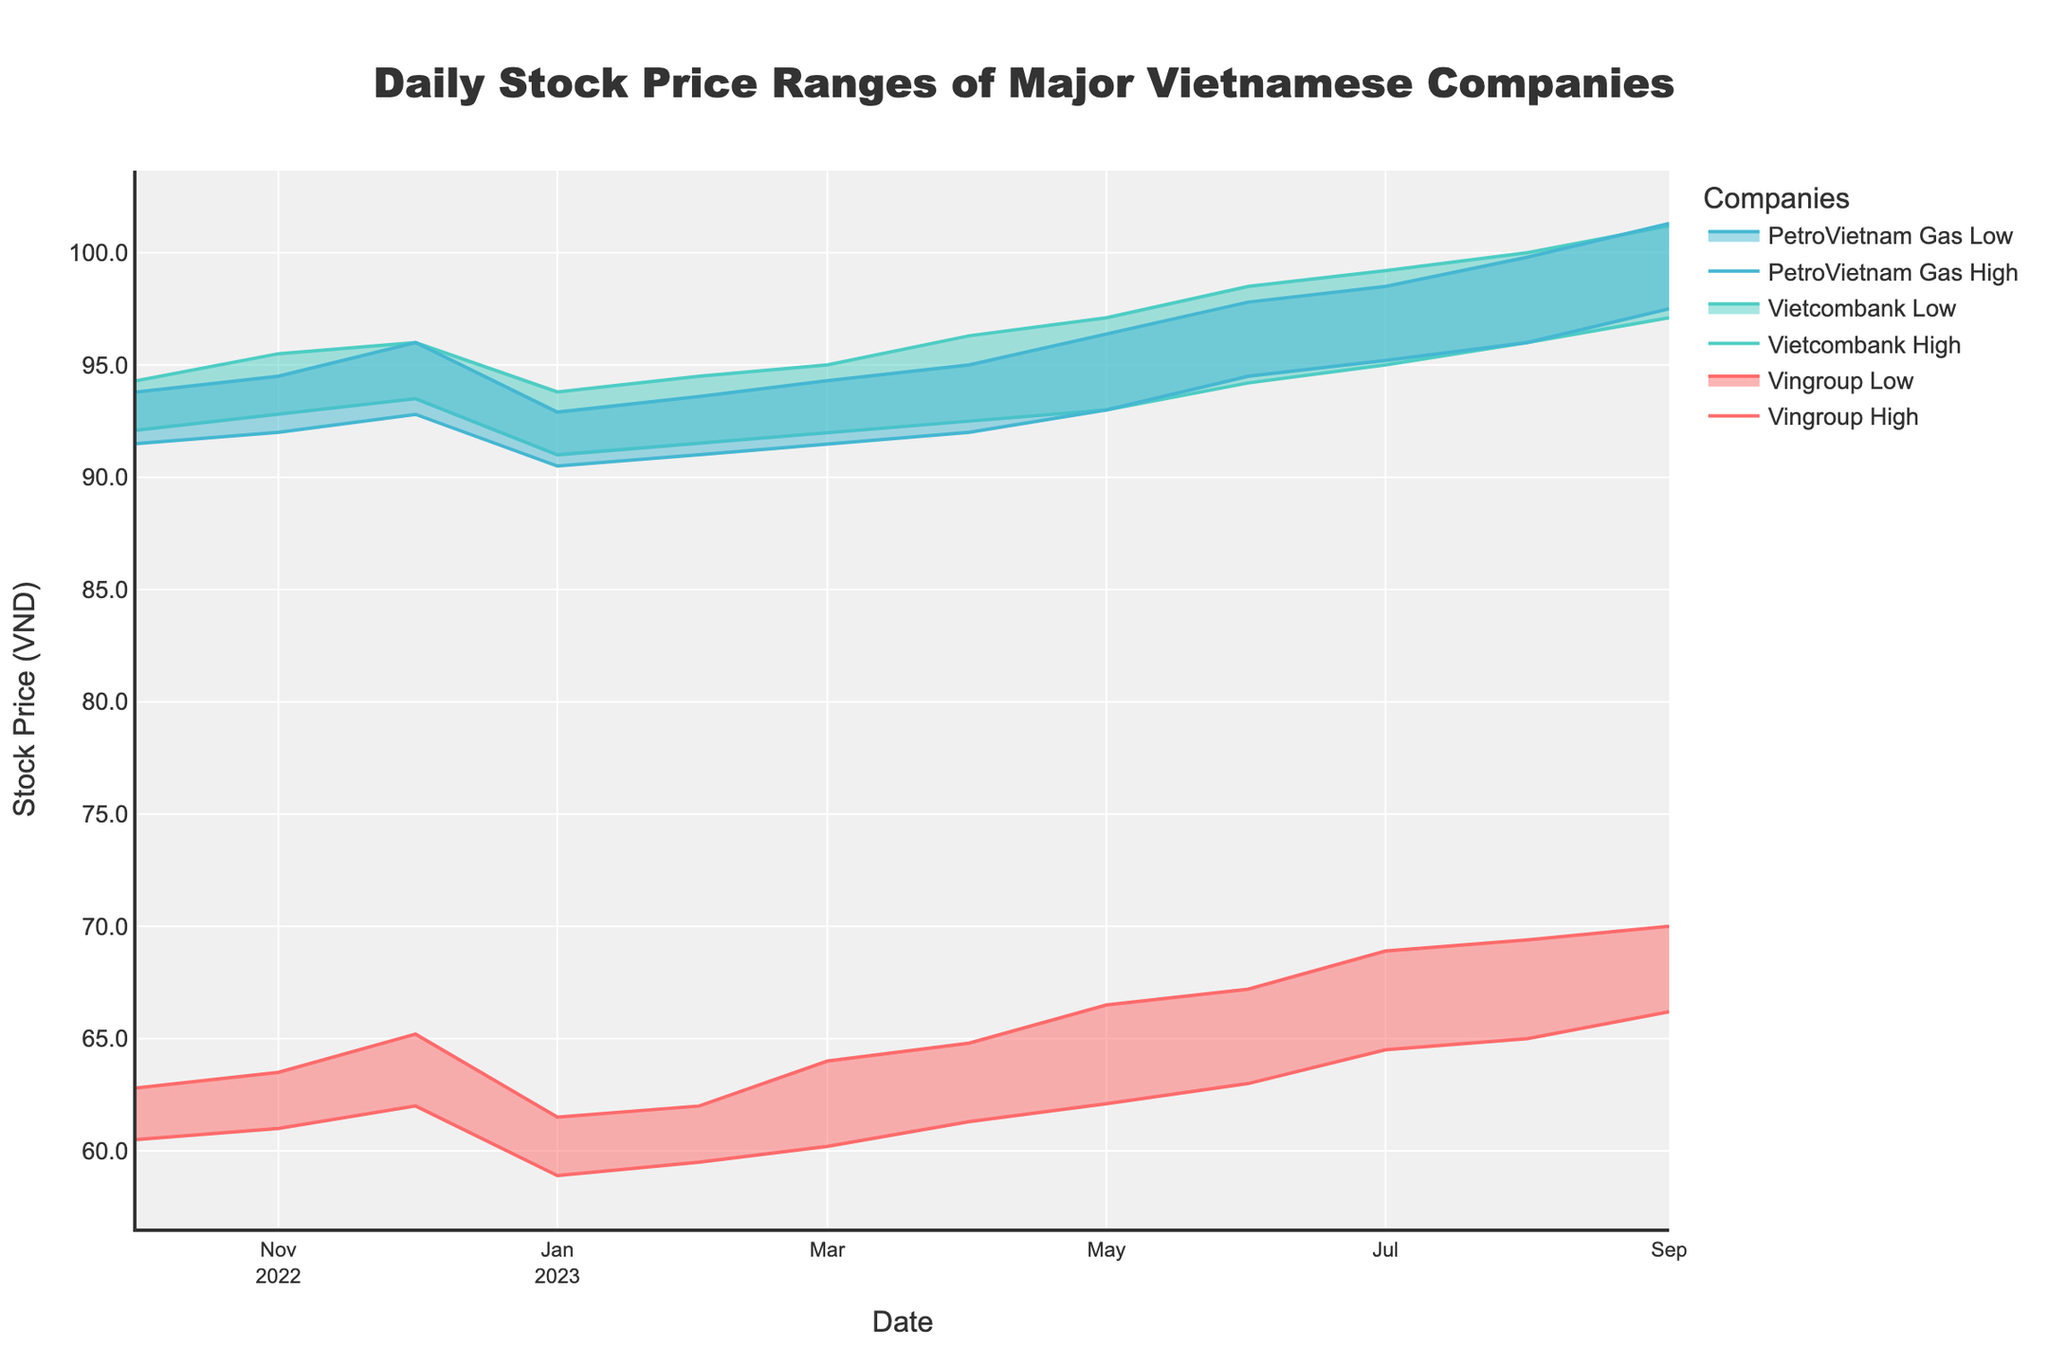what is the color used for Vingroup stock prices? The color assigned to Vingroup stock prices is evident from the lines representing Vingroup in the chart.
Answer: Red In April 2023, what was the difference between the high and low prices of Vingroup’s stock? In the chart, find the high and low prices of Vingroup in April 2023. The high price is 64.8 and the low price is 61.3. The difference is 64.8 - 61.3 = 3.5.
Answer: 3.5 How did the stock range for Vietcombank change from October 2022 to September 2023? To understand the change, observe Vietcombank's high and low prices in October 2022 (94.3 and 92.1 respectively) and September 2023 (101.2 and 97.1 respectively). The range increased from 2.2 in October 2022 to 4.1 in September 2023.
Answer: It increased Comparing Vingroup and Vietcombank, which company had the higher peak stock price over the past year? Identify the highest peak prices for both companies. Vingroup's peak is 70.0 in September 2023, while Vietcombank's peak is 101.2 in September 2023.
Answer: Vietcombank What month did PetroVietnam Gas first exceed a high stock price of 97? Look for the first month where PetroVietnam Gas's high stock price exceeds 97. This occurred in June 2023.
Answer: June 2023 Which company had the smallest increase in low stock price from October 2022 to September 2023? Calculate the increase in low stock prices for each company. Vingroup (66.2 - 60.5 = 5.7), Vietcombank (97.1 - 92.1 = 5.0), and PetroVietnam Gas (97.5 - 91.5 = 6.0). Vietcombank had the smallest increase.
Answer: Vietcombank What is the pattern of Vingroup's stock prices from January 2023 to September 2023? Examine the range area for Vingroup from January to September 2023. The low prices exhibit an upward trend from 58.9 to 66.2 and similarly, the high prices exhibit an upward trend from 61.5 to 70.0.
Answer: Increasing trend In which month did PetroVietnam Gas have its highest low stock price? Look for the peak of the low price for PetroVietnam Gas. The highest low price was in September 2023, at 97.5.
Answer: September 2023 By how much did Vietcombank’s high price change on average per month from June 2023 to September 2023? Calculate the difference in high price for each month: July (99.2-98.5=0.7), August (100.0-99.2=0.8), September (101.2-100.0=1.2). Average change = (0.7+0.8+1.2)/3 = 0.9.
Answer: 0.9 